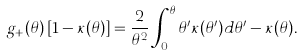Convert formula to latex. <formula><loc_0><loc_0><loc_500><loc_500>g _ { + } ( \theta ) \left [ 1 - \kappa ( \theta ) \right ] = \frac { 2 } { \theta ^ { 2 } } \int _ { 0 } ^ { \theta } \theta ^ { \prime } \kappa ( \theta ^ { \prime } ) d \theta ^ { \prime } - \kappa ( \theta ) .</formula> 